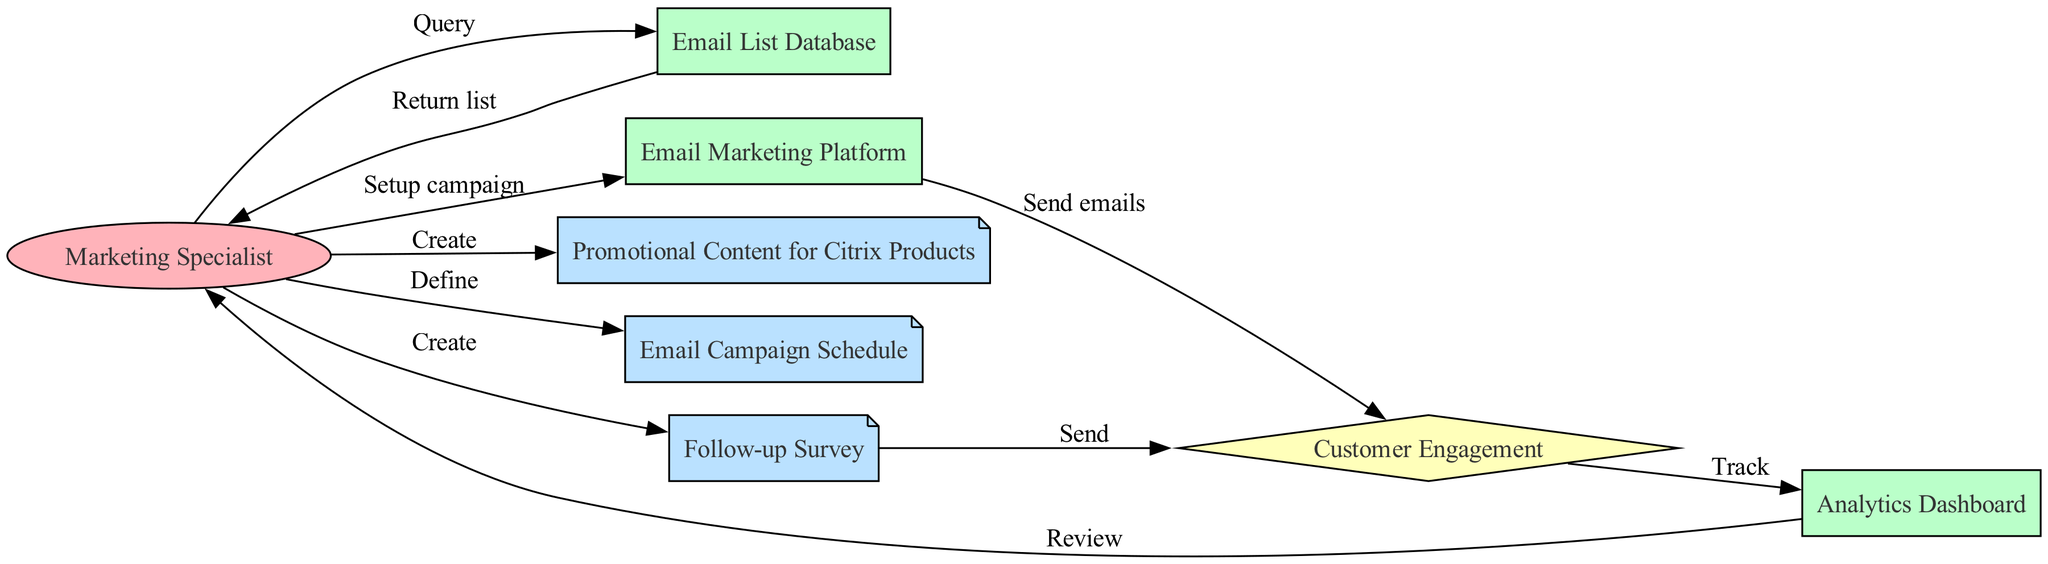What is the role of the Marketing Specialist? The Marketing Specialist is identified as the actor initiating the process by querying the Email List Database and performing various actions throughout the email marketing campaign workflow.
Answer: Actor How many systems are represented in the diagram? The diagram includes three distinct systems: the Email List Database, the Email Marketing Platform, and the Analytics Dashboard.
Answer: Three What is the first action taken by the Marketing Specialist? The first action taken by the Marketing Specialist is querying the Email List Database to obtain the email list.
Answer: Query What is sent after the Customer Engagement occurs? After Customer Engagement occurs, a Follow-up Survey is created and sent to the customers.
Answer: Follow-up Survey How many edges connect the Email Marketing Platform to other elements? The Email Marketing Platform has a single edge leading to Customer Engagement, indicating that it sends emails as part of the process.
Answer: One What does the Marketing Specialist do after tracking on the Analytics Dashboard? After tracking on the Analytics Dashboard, the Marketing Specialist reviews the analytics data collected during the campaign.
Answer: Review What artifact defines the timing of the email campaign? The Email Campaign Schedule is the artifact that defines when the emails will be sent during the promotional campaign.
Answer: Email Campaign Schedule How does the workflow culminate after emails are sent? The workflow culminates with the Analytics Dashboard tracking customer engagement following the email sends, leading to a review by the Marketing Specialist.
Answer: Track What is the purpose of creating promotional content in this workflow? The purpose of creating promotional content is to develop engaging materials that will be sent to customers during the email campaign for Citrix products.
Answer: Create 